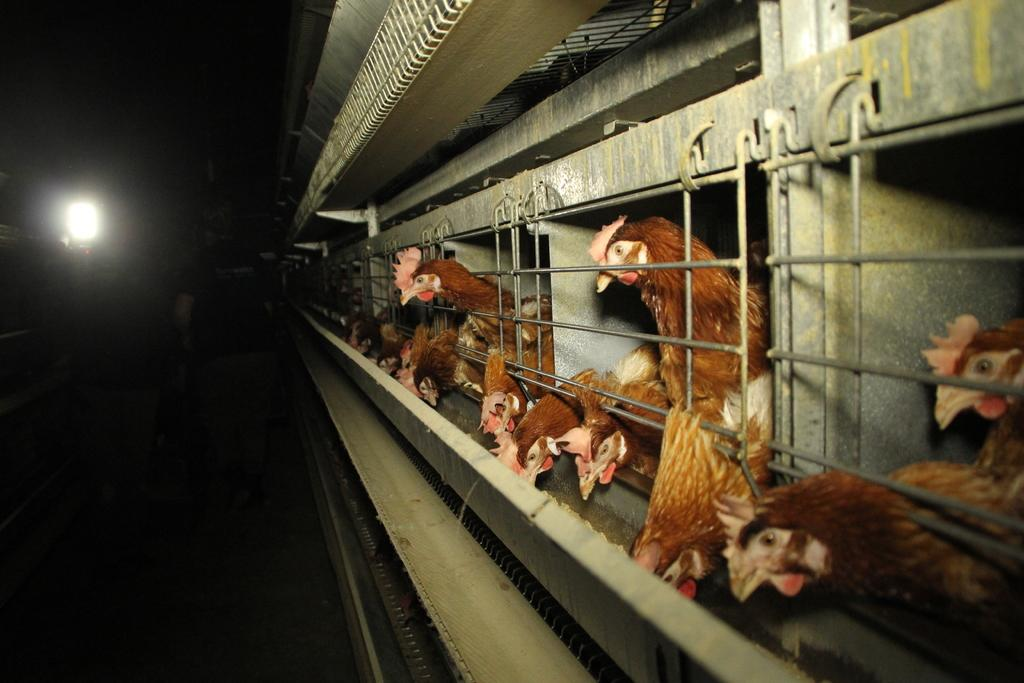Where was the image taken? The image was taken inside a poultry. What can be seen behind the fence in the image? There are hens behind the fence. What are some of the hens doing in the image? Some hens are eating food. Can you describe the person in the image? There is a person standing on the floor. What is the source of light in the image? There is a light on the left side of the image. What type of credit card is the person holding in the image? There is no credit card visible in the image; the person is standing on the floor without any visible objects in their hands. 